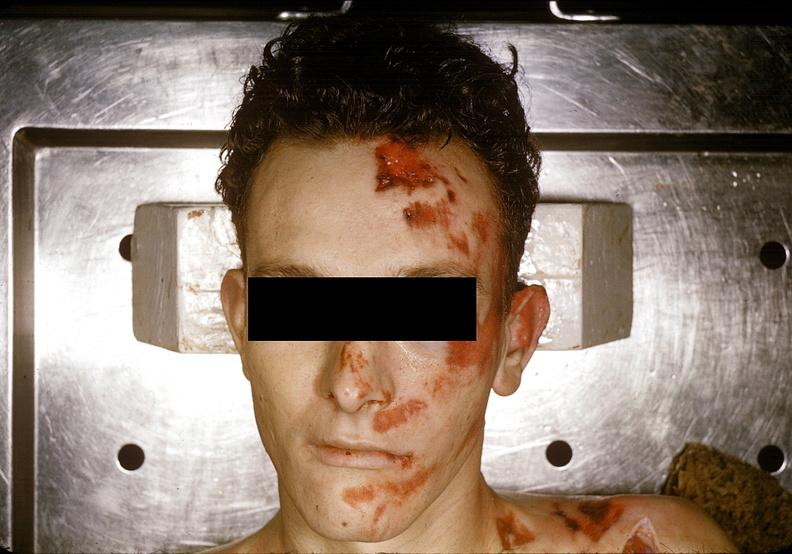does granulomata slide show head and face, severe trauma, contusion, lacerations, abrasions?
Answer the question using a single word or phrase. No 